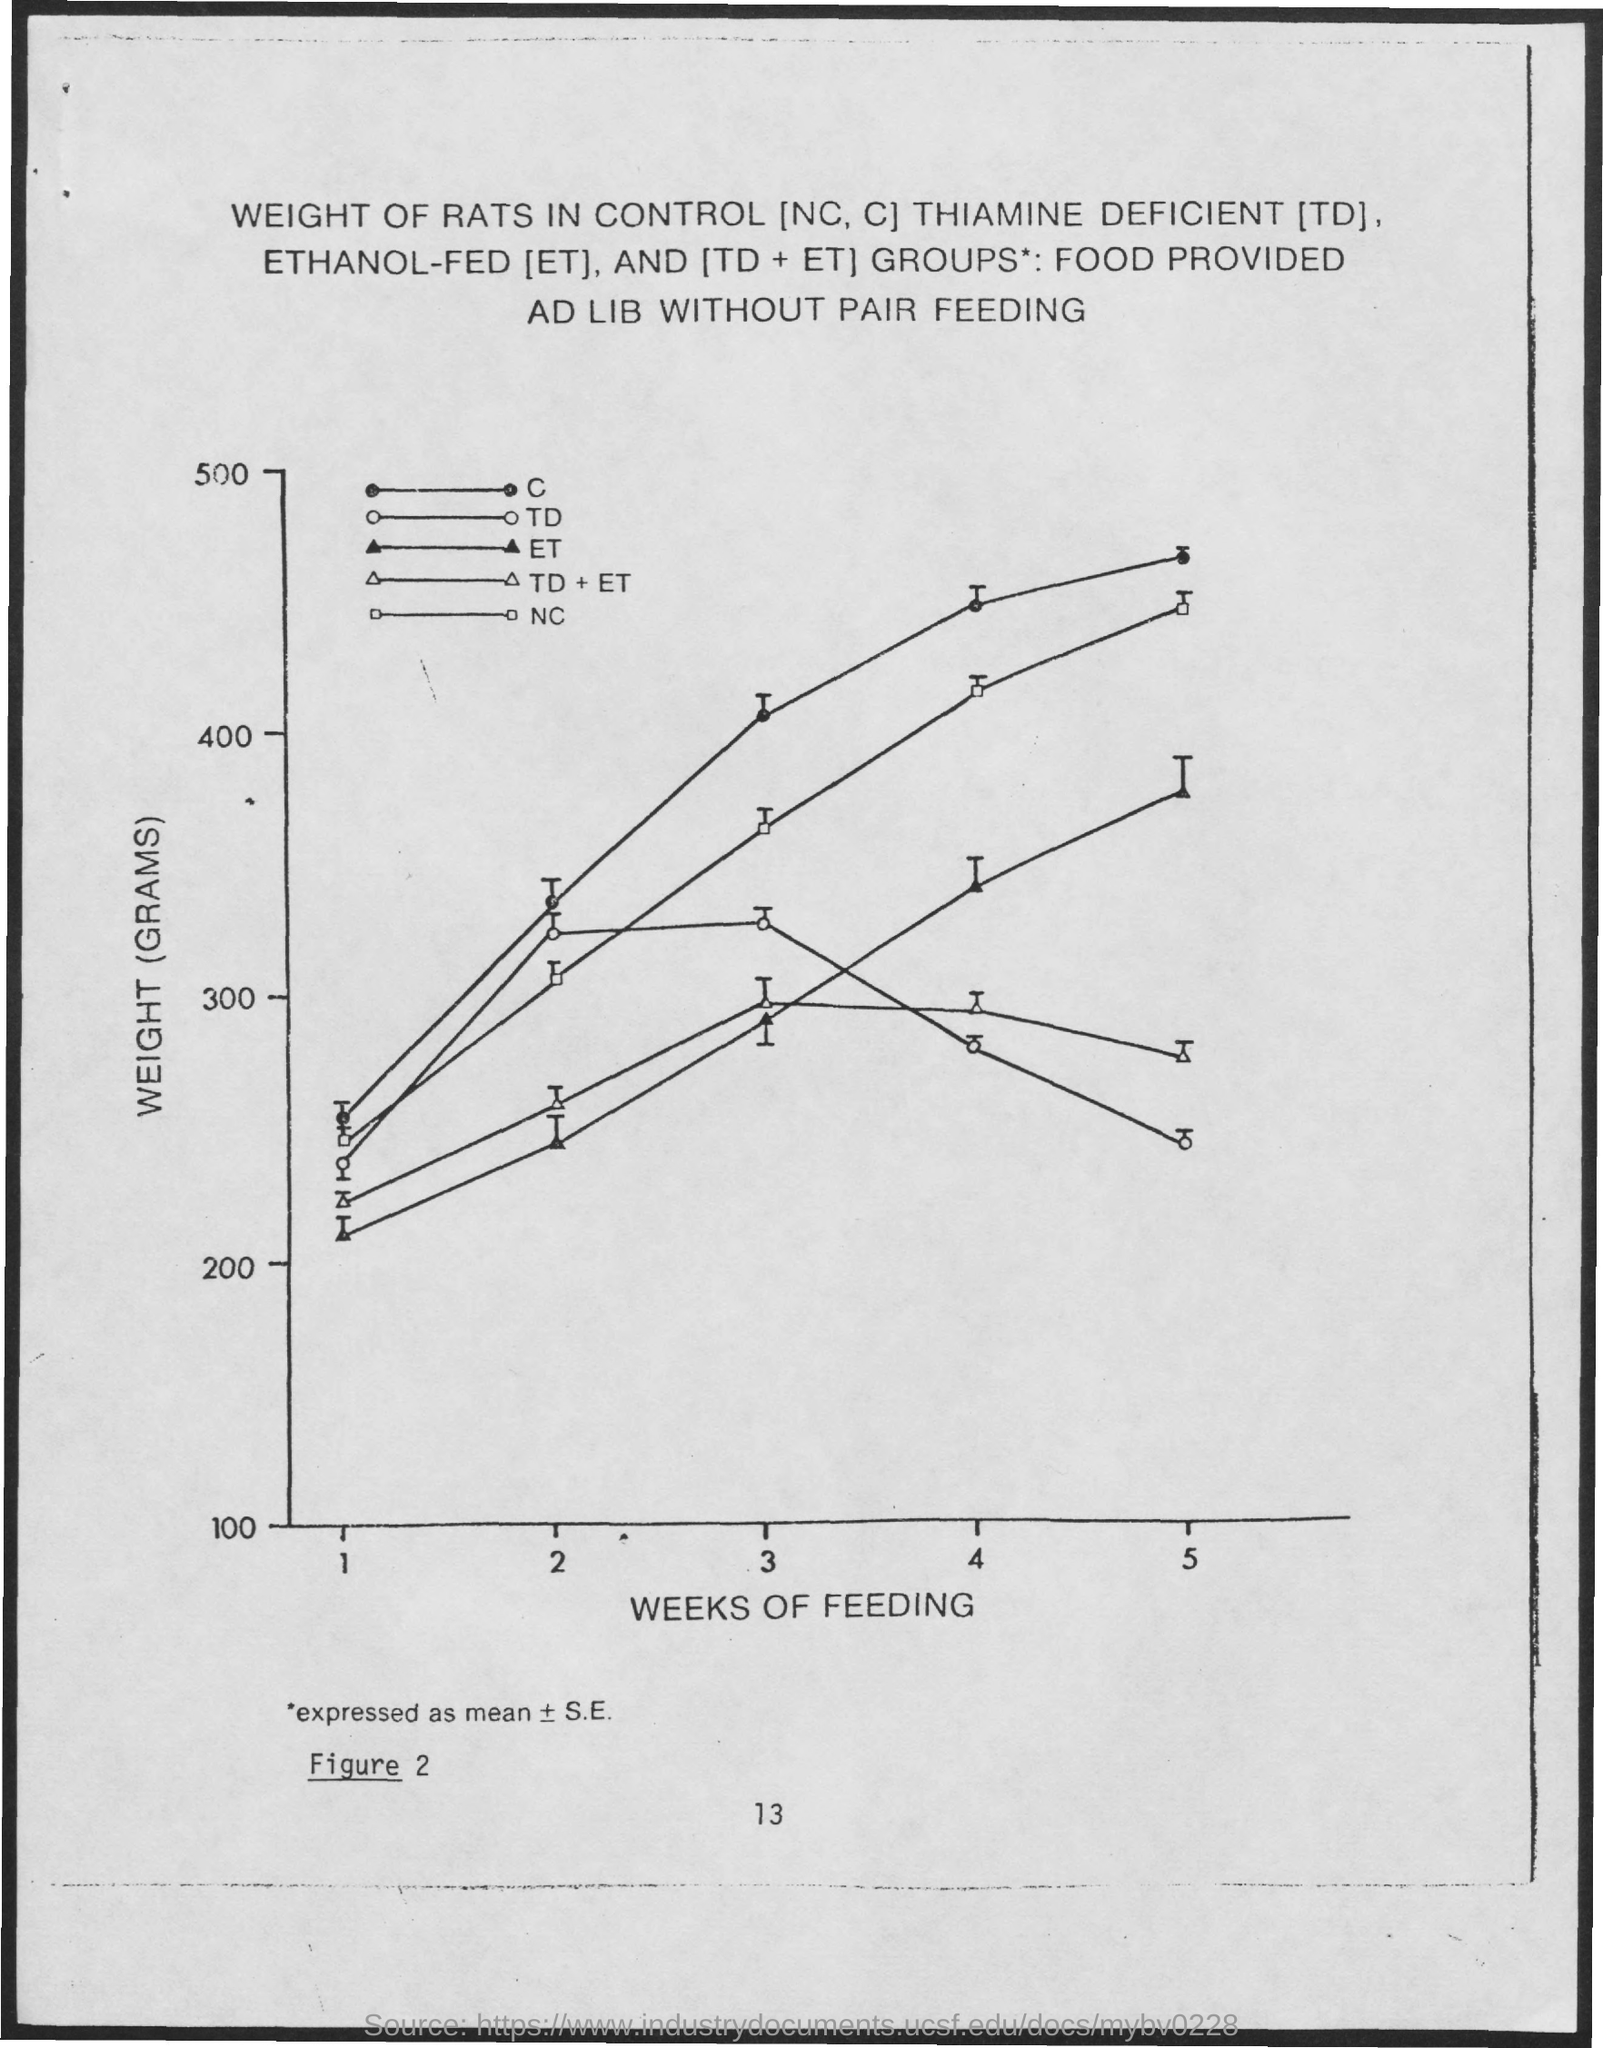Specify some key components in this picture. The x-axis represents the number of weeks of breastfeeding, providing important information for understanding the trend of the data. The Y-axis is the vertical axis on a graph that represents the weight (in grams) of the data being plotted. Thiamine Deficient" is commonly referred to as "TD. 